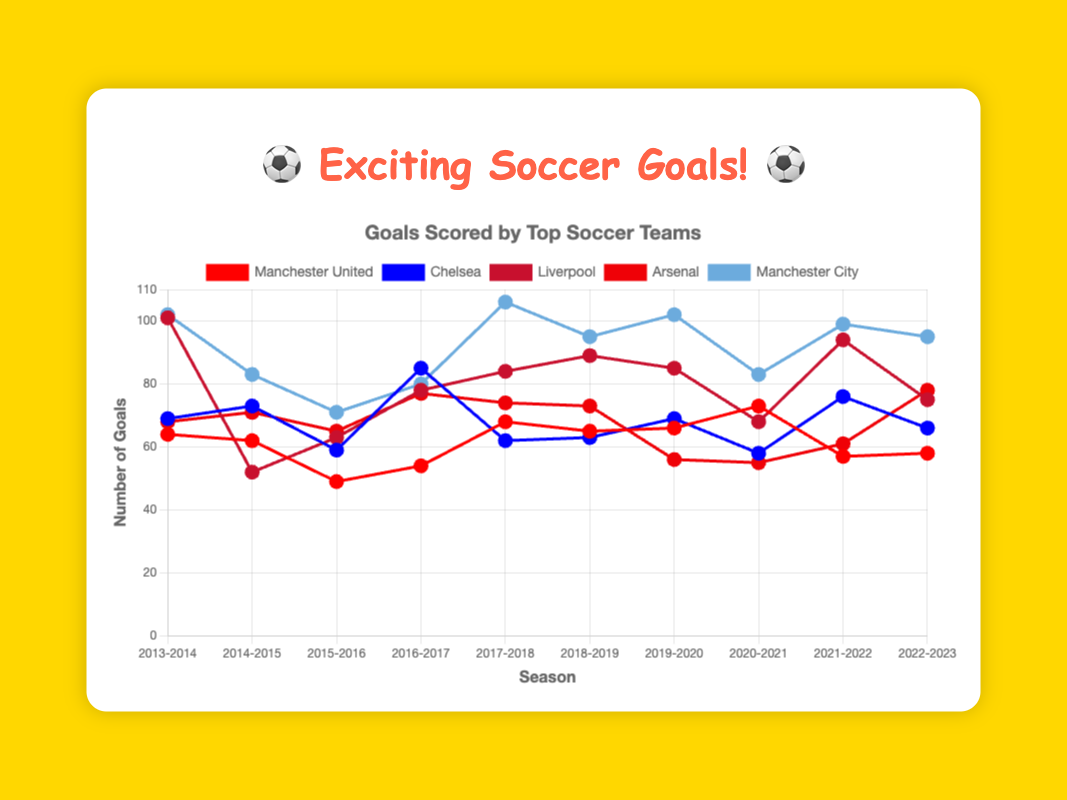Which team scored the most goals in the 2017-2018 season? In the 2017-2018 season, Manchester City scored the highest number of goals, which is depicted by the highest point on the graph for that season.
Answer: Manchester City Compare the number of goals scored by Liverpool and Arsenal in the 2021-2022 season. Which team scored more? In the 2021-2022 season, Liverpool's line is higher than Arsenal's line on the graph, indicating that Liverpool scored more goals.
Answer: Liverpool What is the average number of goals scored by Chelsea over the 10 seasons? To find the average, sum up Chelsea's goals across all seasons and divide by 10. The calculation is (69 + 73 + 59 + 85 + 62 + 63 + 69 + 58 + 76 + 66) / 10 = 680 / 10.
Answer: 68 Which two seasons had the biggest difference in goals scored by Manchester United? The two seasons with the largest difference in goals for Manchester United are 2015-2016 (49 goals) and 2020-2021 (73 goals). The difference is calculated as 73 - 49.
Answer: 24 Between 2018-2019 and 2019-2020, did Arsenal's goals increase or decrease? Comparing the positions of Arsenal's lines for the 2018-2019 and 2019-2020 seasons, there is a decrease in the number of goals from 73 to 56.
Answer: Decrease Which season did Manchester City score the most goals, and how many were they? The season when Manchester City scored the most goals is 2017-2018, indicated by the peak point in Manchester City's line, with 106 goals.
Answer: 2017-2018, 106 What was the total number of goals scored by Arsenal and Chelsea in the 2020-2021 season? The number of goals scored by Arsenal in the 2020-2021 season is 55, and Chelsea scored 58. Their total is 55 + 58.
Answer: 113 How does the trend in goals scored by Manchester United over the last 10 seasons look like? By examining Manchester United's line across the seasons, one can observe that their goals fluctuate but generally stay within a relatively moderate range without sharply increasing or decreasing.
Answer: Fluctuating What is the median number of goals scored by Liverpool over the 10 seasons? To find the median, list Liverpool's goals in ascending order: 52, 63, 68, 75, 78, 84, 85, 89, 94, 101. The median of these 10 values is the average of the 5th and 6th values: (78 + 84) / 2.
Answer: 81 In which season did Chelsea experience the largest drop in goals compared to the previous season? The largest drop for Chelsea occurred from 2016-2017 to 2017-2018, going from 85 to 62 goals. The difference is 85 - 62.
Answer: 2017-2018, 23 